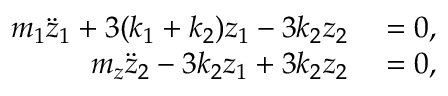<formula> <loc_0><loc_0><loc_500><loc_500>\begin{array} { r l } { m _ { 1 } \ddot { z } _ { 1 } + 3 ( k _ { 1 } + k _ { 2 } ) z _ { 1 } - 3 k _ { 2 } z _ { 2 } } & = 0 , } \\ { m _ { z } \ddot { z } _ { 2 } - 3 k _ { 2 } z _ { 1 } + 3 k _ { 2 } z _ { 2 } } & = 0 , } \end{array}</formula> 